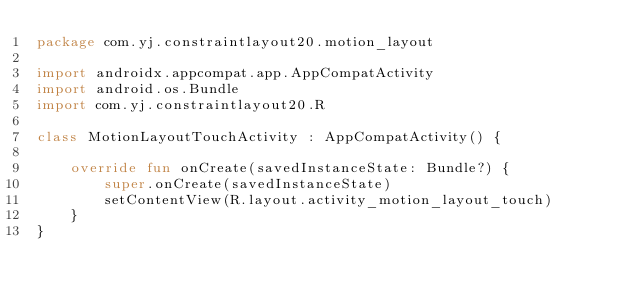Convert code to text. <code><loc_0><loc_0><loc_500><loc_500><_Kotlin_>package com.yj.constraintlayout20.motion_layout

import androidx.appcompat.app.AppCompatActivity
import android.os.Bundle
import com.yj.constraintlayout20.R

class MotionLayoutTouchActivity : AppCompatActivity() {

    override fun onCreate(savedInstanceState: Bundle?) {
        super.onCreate(savedInstanceState)
        setContentView(R.layout.activity_motion_layout_touch)
    }
}
</code> 